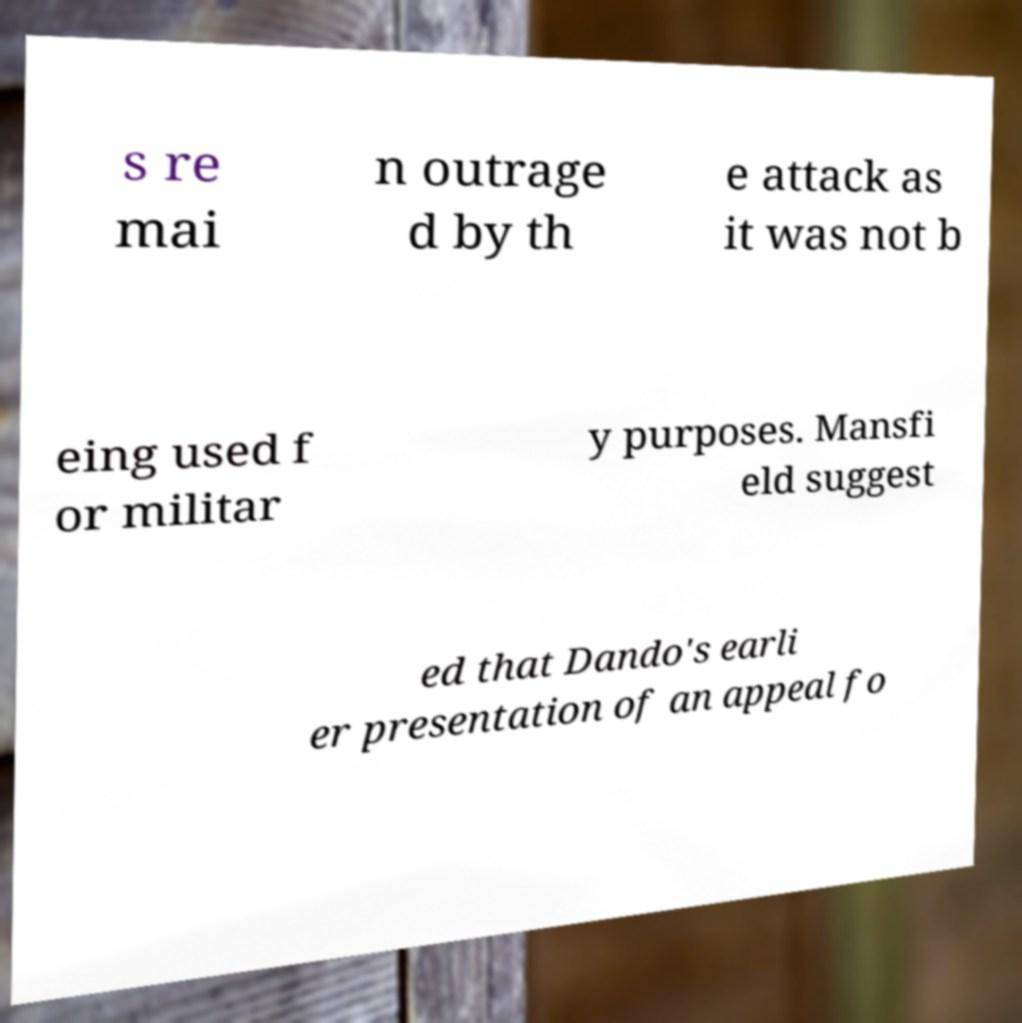What messages or text are displayed in this image? I need them in a readable, typed format. s re mai n outrage d by th e attack as it was not b eing used f or militar y purposes. Mansfi eld suggest ed that Dando's earli er presentation of an appeal fo 